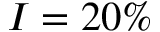Convert formula to latex. <formula><loc_0><loc_0><loc_500><loc_500>I = 2 0 \%</formula> 